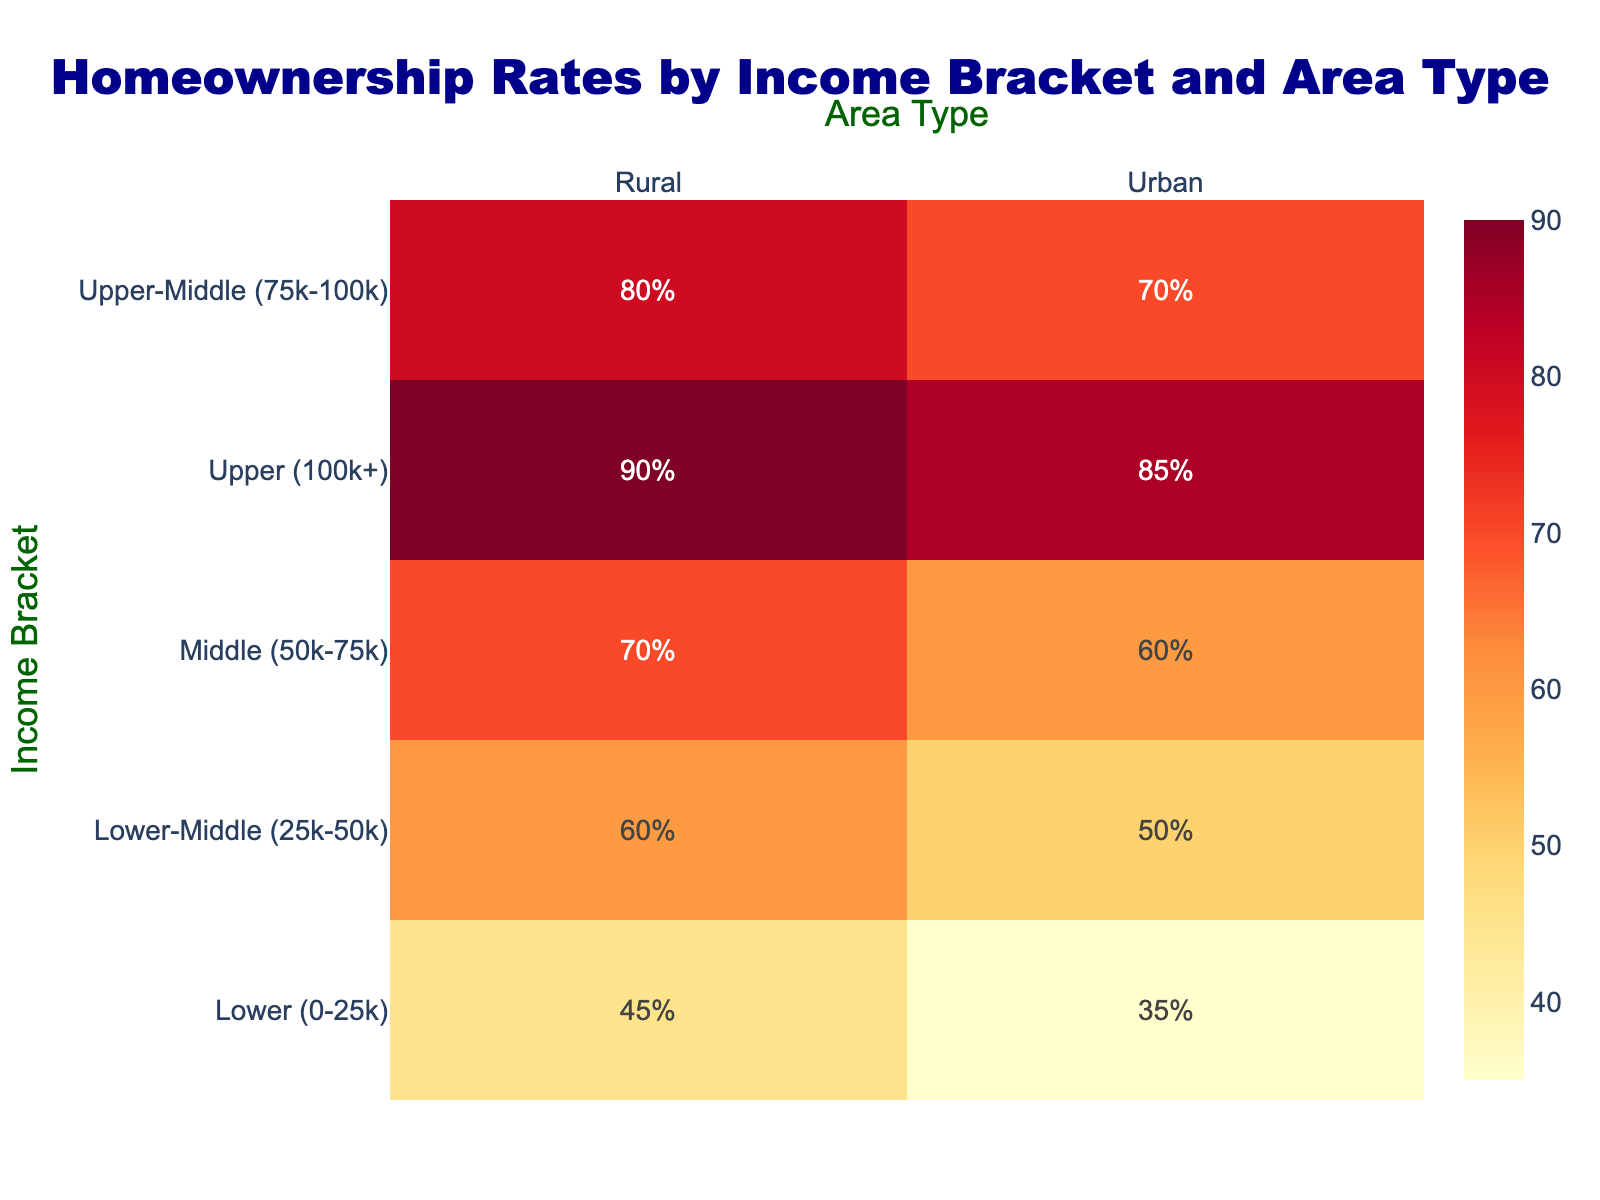What does the title of the heatmap indicate? The title of the heatmap, "Homeownership Rates by Income Bracket and Area Type," indicates that the figure displays the percentage of homeownership across different income groups and differentiates between urban and rural areas.
Answer: Homeownership Rates by Income Bracket and Area Type Which type of area has a higher homeownership rate for the "Lower (0-25k)" income bracket? For the "Lower (0-25k)" income bracket, rural areas have a higher homeownership rate compared to urban areas.
Answer: Rural What is the homeownership rate for the "Upper (100k+)" income bracket in urban areas? To find this, locate the cell at the intersection of the "Upper (100k+)" bracket row and the "Urban" column. The value is 85%.
Answer: 85% Which income bracket shows the smallest difference in homeownership rates between urban and rural areas? By analyzing the differences: "Lower (0-25k)" is 10%, "Lower-Middle (25k-50k)" is 10%, "Middle (50k-75k)" is 10%, "Upper-Middle (75k-100k)" is 10%, and "Upper (100k+)" is 5%. The smallest difference is in the "Upper (100k+)" category.
Answer: Upper (100k+) What is the average homeownership rate for rural areas across all income brackets? Sum the rates for rural areas (45 + 60 + 70 + 80 + 90) and divide by the number of income brackets (5). The sum is 345, and 345 / 5 = 69%.
Answer: 69% How does the homeownership rate for "Middle (50k-75k)" income bracket in urban areas compare to that in rural areas? In the "Middle (50k-75k)" income bracket, urban areas have a homeownership rate of 60%, while rural areas have a rate of 70%. Therefore, rural areas have a 10 percentage points higher rate.
Answer: Rural areas are higher by 10 percentage points What is the trend in homeownership rates in urban areas as income brackets increase from "Lower (0-25k)" to "Upper (100k+)"? The homeownership rates in urban areas show an increasing trend from 35% in the "Lower (0-25k)" bracket to 85% in the "Upper (100k+)" bracket.
Answer: Increasing For which income bracket is the gap between urban and rural homeownership rates the largest? The largest gaps between urban and rural rates are 10% for all brackets, except for "Upper (100k+)" where it is 5%. There is no single largest gap; all but the "Upper (100k+)" bracket have a 10% gap.
Answer: All except "Upper (100k+)" What is the overall pattern observed regarding homeownership rates in rural vs. urban areas across different income brackets? In general, rural areas tend to have higher homeownership rates across all income brackets compared to urban areas.
Answer: Rural areas have higher rates across all brackets 